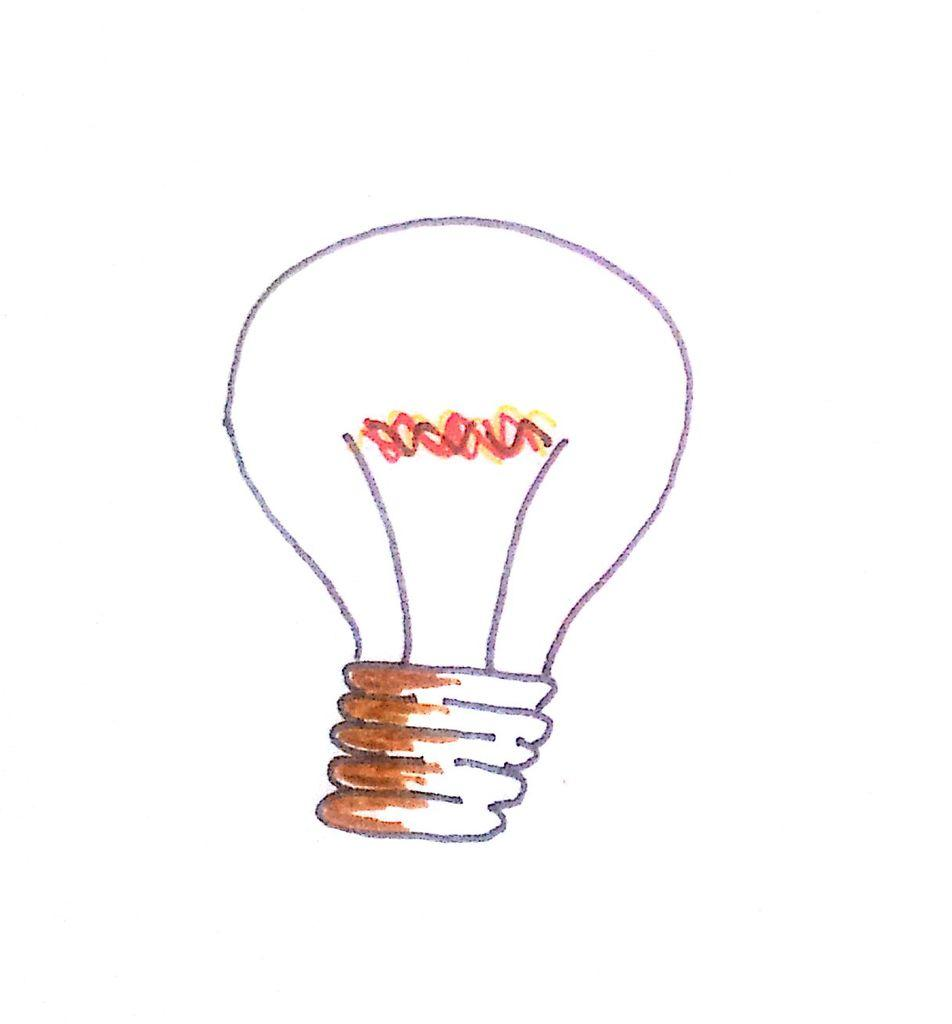What is depicted in the drawing in the image? There is a drawing of a bulb in the image. What is the color of the surface on which the drawing is made? The drawing is on a white surface. What type of business is being conducted in the image? There is no indication of any business being conducted in the image; it only features a drawing of a bulb on a white surface. 